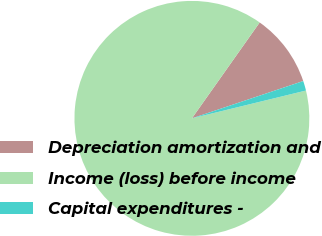<chart> <loc_0><loc_0><loc_500><loc_500><pie_chart><fcel>Depreciation amortization and<fcel>Income (loss) before income<fcel>Capital expenditures -<nl><fcel>10.06%<fcel>88.6%<fcel>1.34%<nl></chart> 